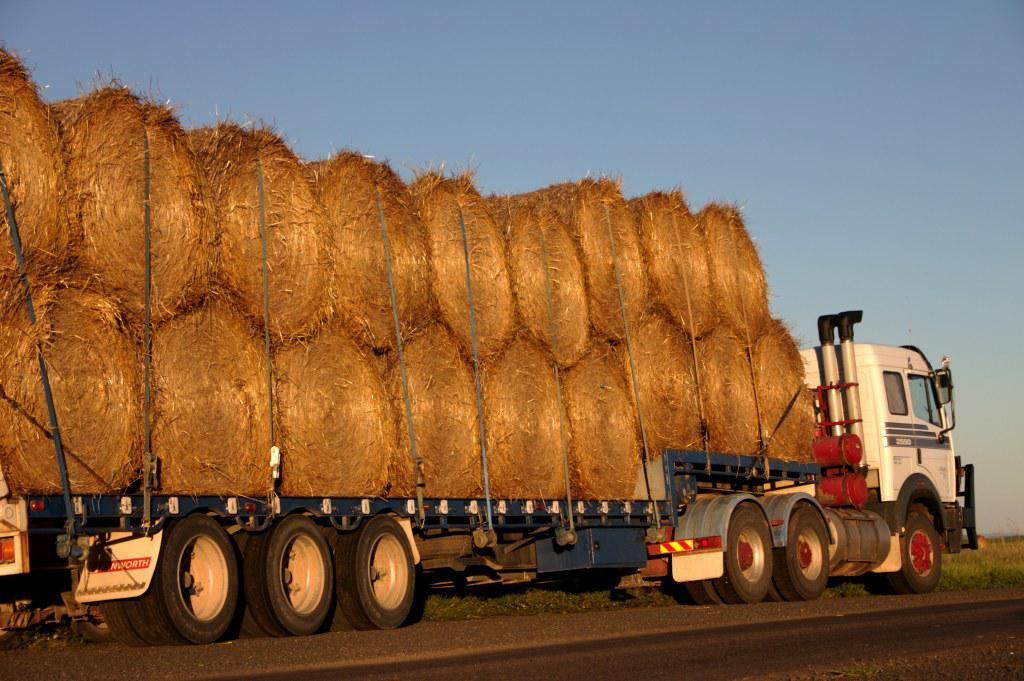What type of vegetation is present in the image? There is grass in the image. What is located on the road in the image? There is a vehicle on the road in the image. What can be seen on the vehicle? There are objects on the vehicle. What is visible in the background of the image? The sky is visible in the background of the image. Where are the chairs placed in the image? There are no chairs present in the image. What type of oven can be seen in the image? There is no oven present in the image. 